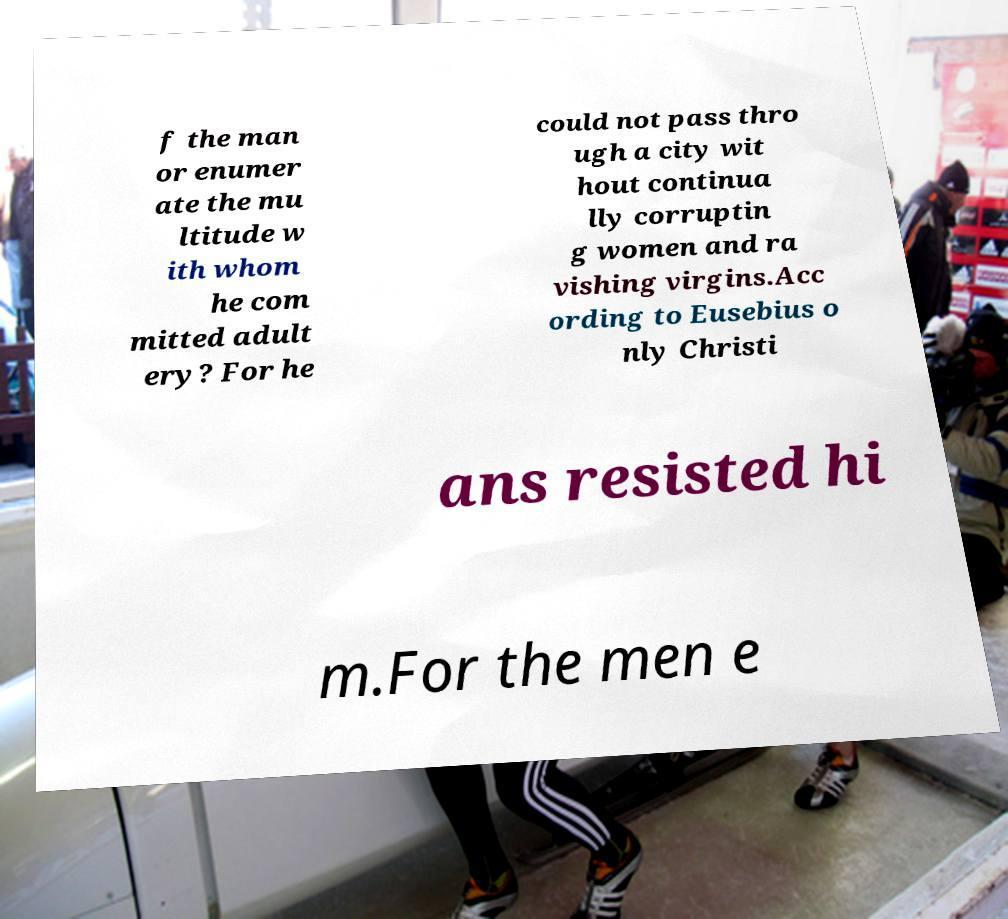I need the written content from this picture converted into text. Can you do that? f the man or enumer ate the mu ltitude w ith whom he com mitted adult ery? For he could not pass thro ugh a city wit hout continua lly corruptin g women and ra vishing virgins.Acc ording to Eusebius o nly Christi ans resisted hi m.For the men e 